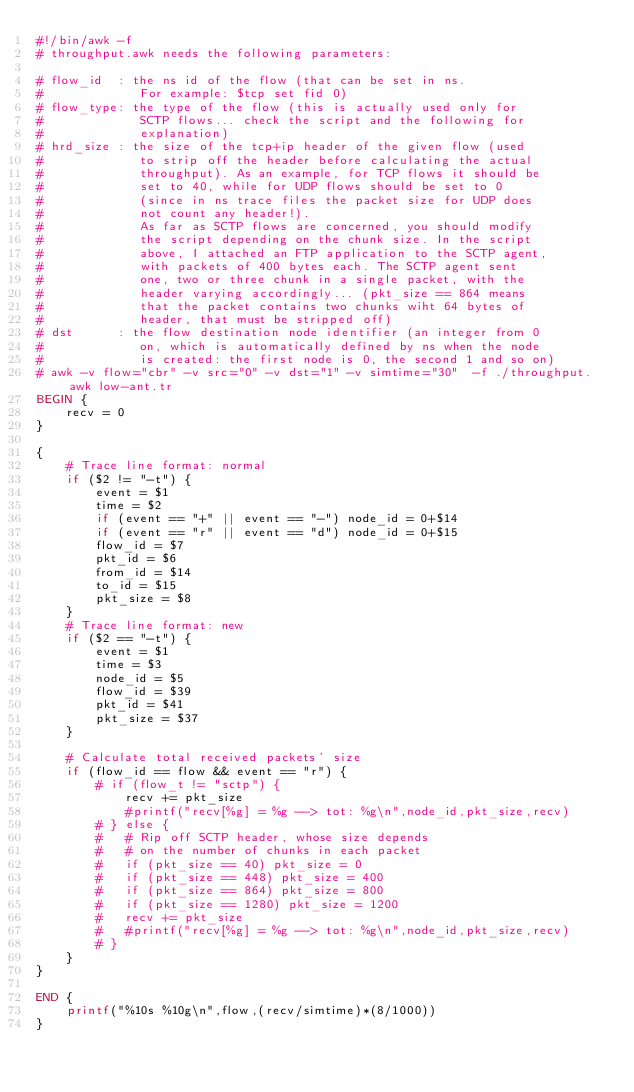Convert code to text. <code><loc_0><loc_0><loc_500><loc_500><_Awk_>#!/bin/awk -f
# throughput.awk needs the following parameters:

# flow_id  : the ns id of the flow (that can be set in ns.
#             For example: $tcp set fid 0)
# flow_type: the type of the flow (this is actually used only for
#             SCTP flows... check the script and the following for
#             explanation)
# hrd_size : the size of the tcp+ip header of the given flow (used
#             to strip off the header before calculating the actual
#             throughput). As an example, for TCP flows it should be
#             set to 40, while for UDP flows should be set to 0
#             (since in ns trace files the packet size for UDP does
#             not count any header!).
#             As far as SCTP flows are concerned, you should modify
#             the script depending on the chunk size. In the script
#             above, I attached an FTP application to the SCTP agent,
#             with packets of 400 bytes each. The SCTP agent sent
#             one, two or three chunk in a single packet, with the
#             header varying accordingly... (pkt_size == 864 means
#             that the packet contains two chunks wiht 64 bytes of
#             header, that must be stripped off)
# dst      : the flow destination node identifier (an integer from 0
#             on, which is automatically defined by ns when the node
#             is created: the first node is 0, the second 1 and so on)
# awk -v flow="cbr" -v src="0" -v dst="1" -v simtime="30"  -f ./throughput.awk low-ant.tr
BEGIN {
	recv = 0
}

{
	# Trace line format: normal
	if ($2 != "-t") {
		event = $1
		time = $2
		if (event == "+" || event == "-") node_id = 0+$14
		if (event == "r" || event == "d") node_id = 0+$15
		flow_id = $7
		pkt_id = $6
		from_id = $14
		to_id = $15
		pkt_size = $8
	}
	# Trace line format: new
	if ($2 == "-t") {
		event = $1
		time = $3
		node_id = $5
		flow_id = $39
		pkt_id = $41
		pkt_size = $37
	}

	# Calculate total received packets' size
	if (flow_id == flow && event == "r") {
		# if (flow_t != "sctp") {
			recv += pkt_size
			#printf("recv[%g] = %g --> tot: %g\n",node_id,pkt_size,recv)
		# } else {
		# 	# Rip off SCTP header, whose size depends
		# 	# on the number of chunks in each packet
		# 	if (pkt_size == 40) pkt_size = 0
		# 	if (pkt_size == 448) pkt_size = 400
		# 	if (pkt_size == 864) pkt_size = 800
		# 	if (pkt_size == 1280) pkt_size = 1200
		# 	recv += pkt_size
		# 	#printf("recv[%g] = %g --> tot: %g\n",node_id,pkt_size,recv)
		# }
	}
}

END {
	printf("%10s %10g\n",flow,(recv/simtime)*(8/1000))
}
</code> 